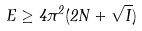Convert formula to latex. <formula><loc_0><loc_0><loc_500><loc_500>E \geq 4 \pi ^ { 2 } ( 2 N + \sqrt { I } )</formula> 